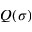Convert formula to latex. <formula><loc_0><loc_0><loc_500><loc_500>Q ( \sigma )</formula> 